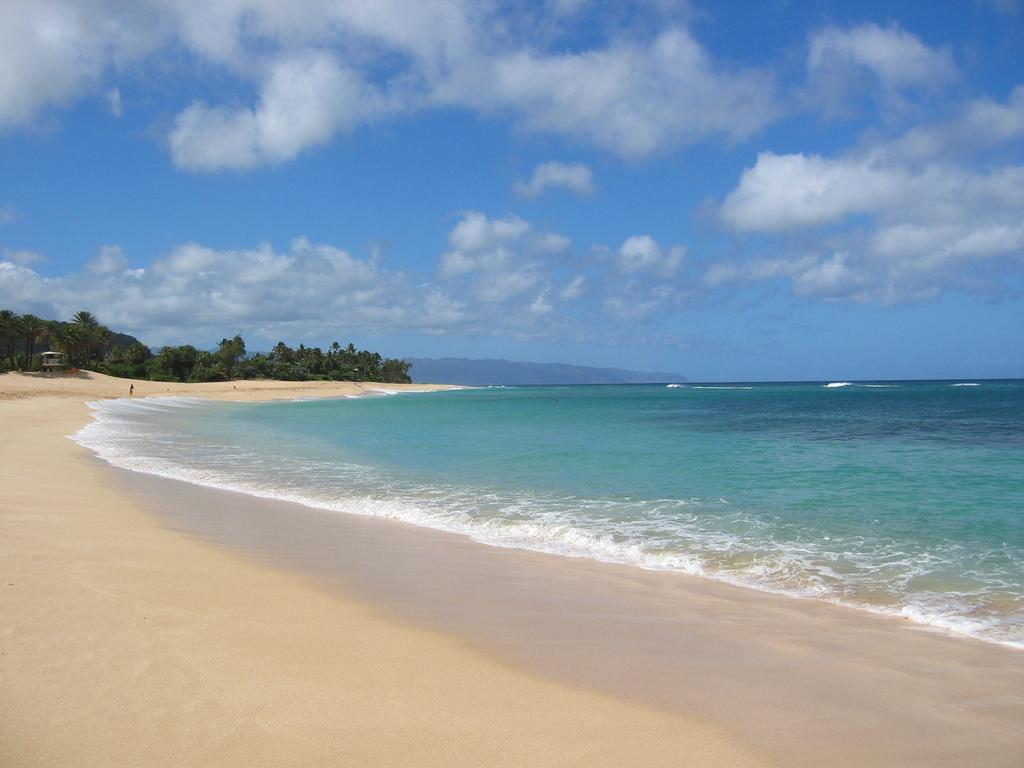What type of natural environment is depicted in the image? The image features a sea, sand, trees, hills, and sky, which suggests a coastal or beach setting. What type of structure can be seen in the image? There is a hut in the image. What is visible in the sky in the image? There are clouds visible in the sky in the image. Can you tell me where the chess pieces are located in the image? There are no chess pieces present in the image. What type of lock is securing the mitten in the image? There is no lock or mitten present in the image. 